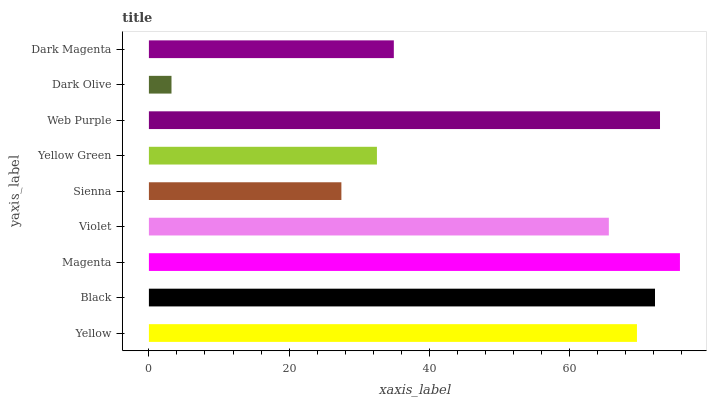Is Dark Olive the minimum?
Answer yes or no. Yes. Is Magenta the maximum?
Answer yes or no. Yes. Is Black the minimum?
Answer yes or no. No. Is Black the maximum?
Answer yes or no. No. Is Black greater than Yellow?
Answer yes or no. Yes. Is Yellow less than Black?
Answer yes or no. Yes. Is Yellow greater than Black?
Answer yes or no. No. Is Black less than Yellow?
Answer yes or no. No. Is Violet the high median?
Answer yes or no. Yes. Is Violet the low median?
Answer yes or no. Yes. Is Yellow the high median?
Answer yes or no. No. Is Yellow Green the low median?
Answer yes or no. No. 